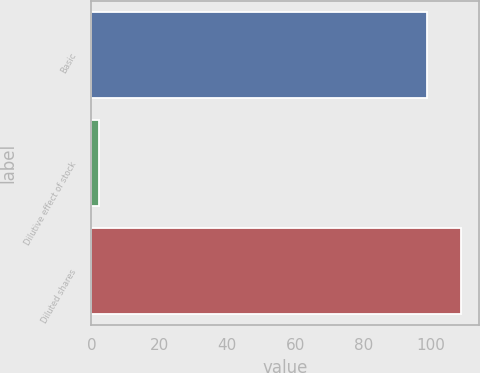<chart> <loc_0><loc_0><loc_500><loc_500><bar_chart><fcel>Basic<fcel>Dilutive effect of stock<fcel>Diluted shares<nl><fcel>98.9<fcel>2.4<fcel>108.79<nl></chart> 